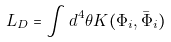<formula> <loc_0><loc_0><loc_500><loc_500>L _ { D } = \int d ^ { 4 } \theta K ( \Phi _ { i } , \bar { \Phi } _ { i } )</formula> 